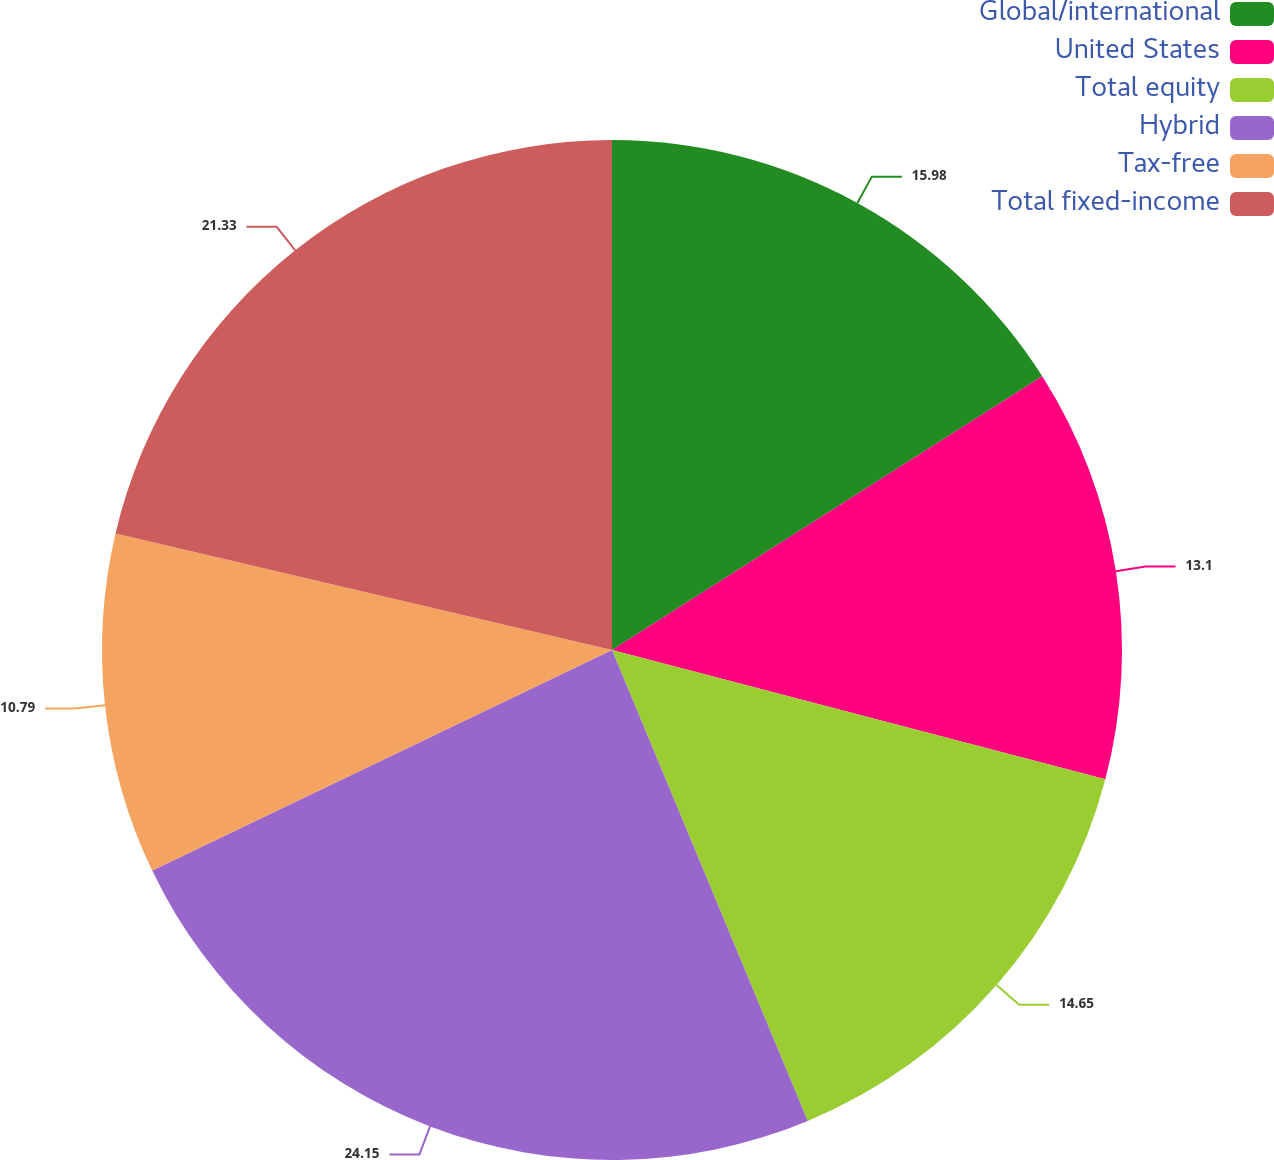Convert chart to OTSL. <chart><loc_0><loc_0><loc_500><loc_500><pie_chart><fcel>Global/international<fcel>United States<fcel>Total equity<fcel>Hybrid<fcel>Tax-free<fcel>Total fixed-income<nl><fcel>15.98%<fcel>13.1%<fcel>14.65%<fcel>24.15%<fcel>10.79%<fcel>21.33%<nl></chart> 